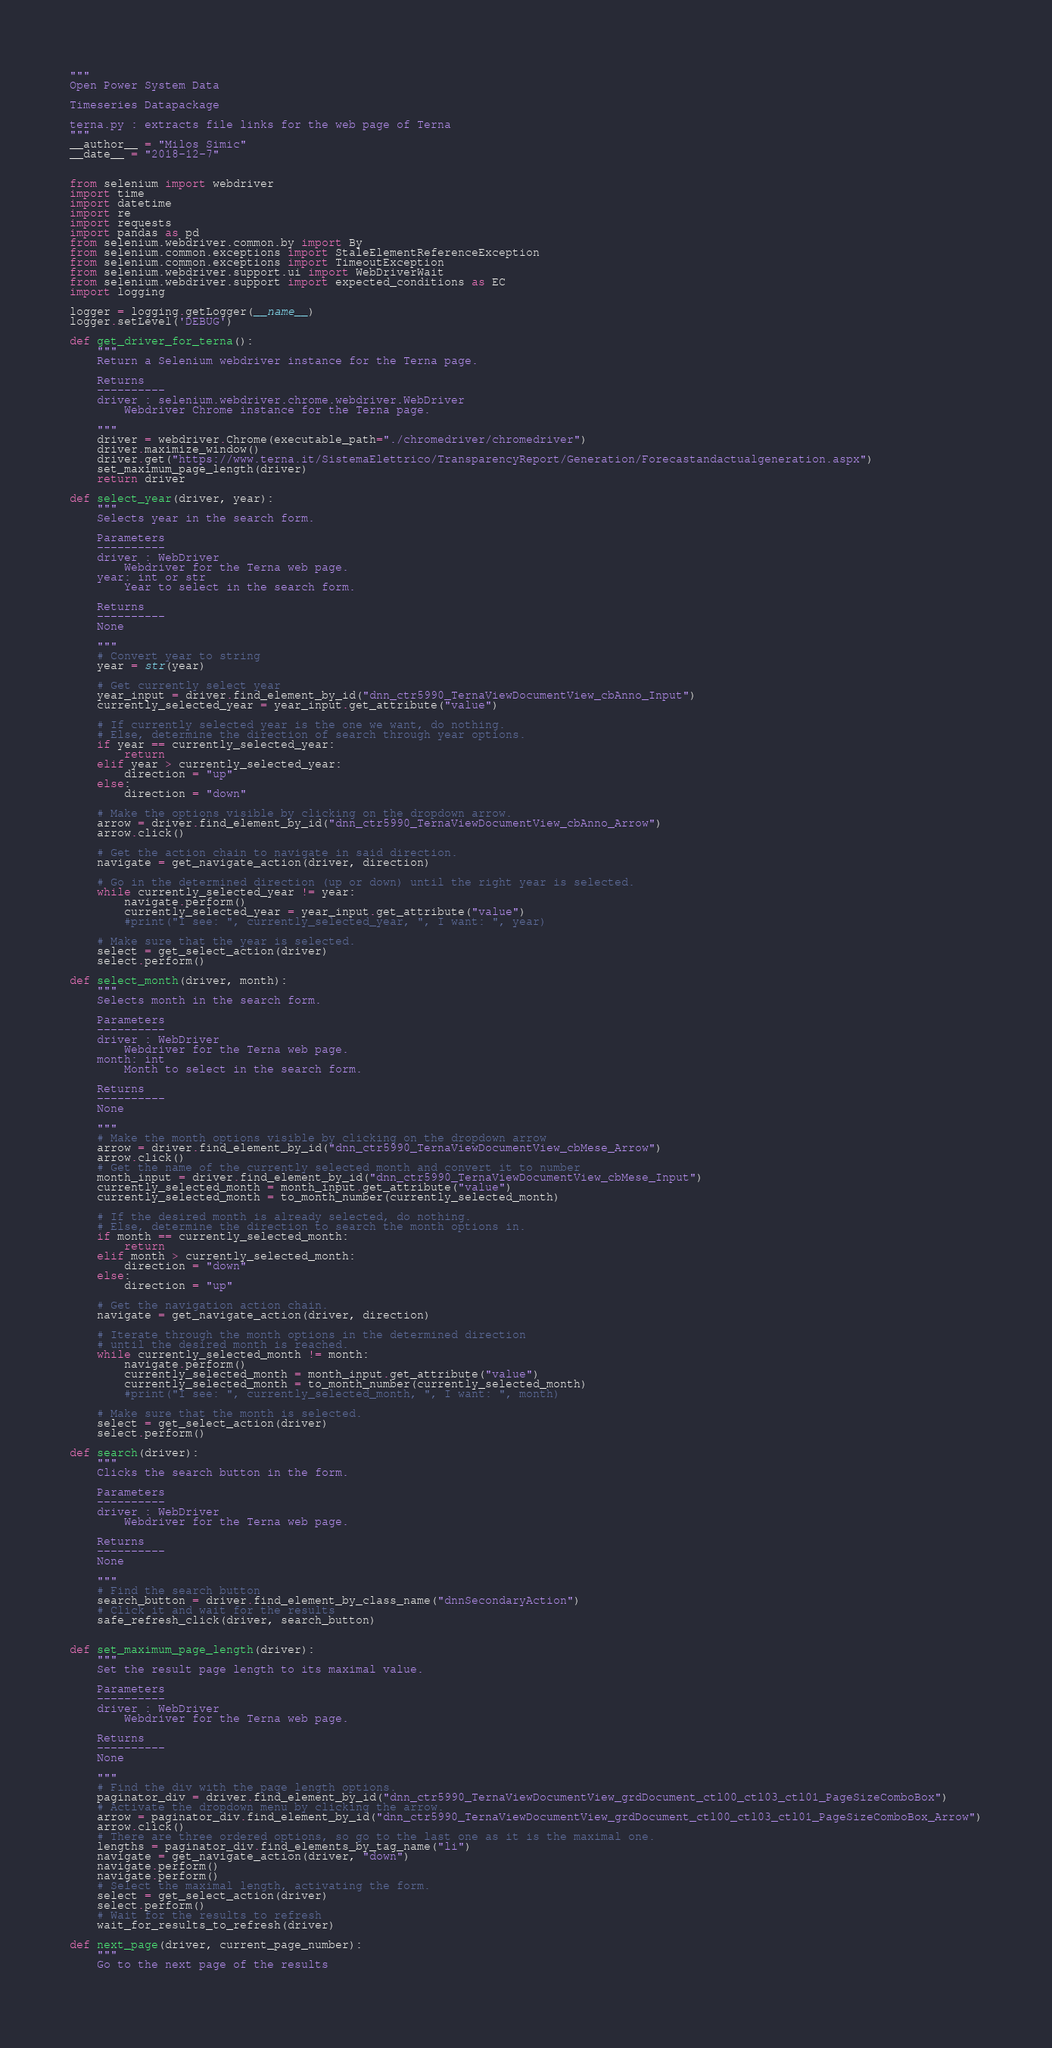<code> <loc_0><loc_0><loc_500><loc_500><_Python_>"""
Open Power System Data

Timeseries Datapackage

terna.py : extracts file links for the web page of Terna
"""
__author__ = "Milos Simic"
__date__ = "2018-12-7"


from selenium import webdriver
import time
import datetime
import re
import requests
import pandas as pd
from selenium.webdriver.common.by import By
from selenium.common.exceptions import StaleElementReferenceException
from selenium.common.exceptions import TimeoutException
from selenium.webdriver.support.ui import WebDriverWait
from selenium.webdriver.support import expected_conditions as EC
import logging

logger = logging.getLogger(__name__)
logger.setLevel('DEBUG')

def get_driver_for_terna():
    """ 
    Return a Selenium webdriver instance for the Terna page.
    
    Returns
    ----------
    driver : selenium.webdriver.chrome.webdriver.WebDriver
        Webdriver Chrome instance for the Terna page.
        
    """
    driver = webdriver.Chrome(executable_path="./chromedriver/chromedriver")
    driver.maximize_window()
    driver.get("https://www.terna.it/SistemaElettrico/TransparencyReport/Generation/Forecastandactualgeneration.aspx")
    set_maximum_page_length(driver)
    return driver

def select_year(driver, year):
    """ 
    Selects year in the search form.
    
    Parameters
    ----------
    driver : WebDriver
        Webdriver for the Terna web page.
    year: int or str
        Year to select in the search form.
       
    Returns
    ----------
    None
    
    """
    # Convert year to string
    year = str(year)
    
    # Get currently select year
    year_input = driver.find_element_by_id("dnn_ctr5990_TernaViewDocumentView_cbAnno_Input")
    currently_selected_year = year_input.get_attribute("value")
    
    # If currently selected year is the one we want, do nothing. 
    # Else, determine the direction of search through year options.
    if year == currently_selected_year:
        return 
    elif year > currently_selected_year:
        direction = "up"
    else:
        direction = "down"
        
    # Make the options visible by clicking on the dropdown arrow.
    arrow = driver.find_element_by_id("dnn_ctr5990_TernaViewDocumentView_cbAnno_Arrow")
    arrow.click()
    
    # Get the action chain to navigate in said direction.
    navigate = get_navigate_action(driver, direction)
    
    # Go in the determined direction (up or down) until the right year is selected.
    while currently_selected_year != year:
        navigate.perform()
        currently_selected_year = year_input.get_attribute("value")
        #print("I see: ", currently_selected_year, ", I want: ", year)
        
    # Make sure that the year is selected.
    select = get_select_action(driver)
    select.perform()

def select_month(driver, month):
    """ 
    Selects month in the search form.
    
    Parameters
    ----------
    driver : WebDriver
        Webdriver for the Terna web page.
    month: int
        Month to select in the search form.
       
    Returns
    ----------
    None
    
    """
    # Make the month options visible by clicking on the dropdown arrow
    arrow = driver.find_element_by_id("dnn_ctr5990_TernaViewDocumentView_cbMese_Arrow")
    arrow.click()
    # Get the name of the currently selected month and convert it to number
    month_input = driver.find_element_by_id("dnn_ctr5990_TernaViewDocumentView_cbMese_Input")
    currently_selected_month = month_input.get_attribute("value")
    currently_selected_month = to_month_number(currently_selected_month)
    
    # If the desired month is already selected, do nothing.
    # Else, determine the direction to search the month options in.
    if month == currently_selected_month:
        return
    elif month > currently_selected_month:
        direction = "down"
    else:
        direction = "up"
    
    # Get the navigation action chain.
    navigate = get_navigate_action(driver, direction)
    
    # Iterate through the month options in the determined direction
    # until the desired month is reached.
    while currently_selected_month != month:
        navigate.perform()
        currently_selected_month = month_input.get_attribute("value")
        currently_selected_month = to_month_number(currently_selected_month)
        #print("I see: ", currently_selected_month, ", I want: ", month)
    
    # Make sure that the month is selected.
    select = get_select_action(driver)
    select.perform()

def search(driver):
    """ 
    Clicks the search button in the form.
    
    Parameters
    ----------
    driver : WebDriver
        Webdriver for the Terna web page.
       
    Returns
    ----------
    None
    
    """
    # Find the search button
    search_button = driver.find_element_by_class_name("dnnSecondaryAction")
    # Click it and wait for the results
    safe_refresh_click(driver, search_button)


def set_maximum_page_length(driver):
    """ 
    Set the result page length to its maximal value.
    
    Parameters
    ----------
    driver : WebDriver
        Webdriver for the Terna web page.
       
    Returns
    ----------
    None
    
    """
    # Find the div with the page length options.
    paginator_div = driver.find_element_by_id("dnn_ctr5990_TernaViewDocumentView_grdDocument_ctl00_ctl03_ctl01_PageSizeComboBox")
    # Activate the dropdown menu by clicking the arrow.
    arrow = paginator_div.find_element_by_id("dnn_ctr5990_TernaViewDocumentView_grdDocument_ctl00_ctl03_ctl01_PageSizeComboBox_Arrow")
    arrow.click()
    # There are three ordered options, so go to the last one as it is the maximal one.
    lengths = paginator_div.find_elements_by_tag_name("li")
    navigate = get_navigate_action(driver, "down")
    navigate.perform()
    navigate.perform()
    # Select the maximal length, activating the form.
    select = get_select_action(driver)
    select.perform()
    # Wait for the results to refresh
    wait_for_results_to_refresh(driver)

def next_page(driver, current_page_number):
    """ 
    Go to the next page of the results
    </code> 